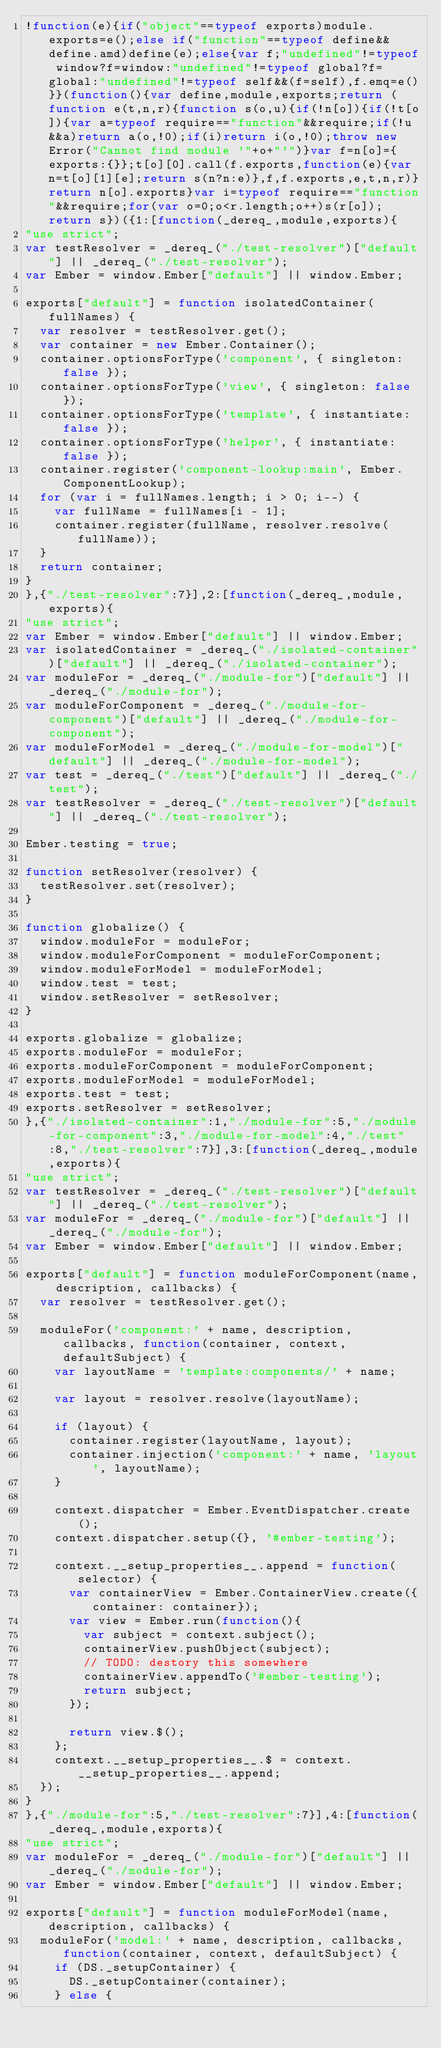<code> <loc_0><loc_0><loc_500><loc_500><_JavaScript_>!function(e){if("object"==typeof exports)module.exports=e();else if("function"==typeof define&&define.amd)define(e);else{var f;"undefined"!=typeof window?f=window:"undefined"!=typeof global?f=global:"undefined"!=typeof self&&(f=self),f.emq=e()}}(function(){var define,module,exports;return (function e(t,n,r){function s(o,u){if(!n[o]){if(!t[o]){var a=typeof require=="function"&&require;if(!u&&a)return a(o,!0);if(i)return i(o,!0);throw new Error("Cannot find module '"+o+"'")}var f=n[o]={exports:{}};t[o][0].call(f.exports,function(e){var n=t[o][1][e];return s(n?n:e)},f,f.exports,e,t,n,r)}return n[o].exports}var i=typeof require=="function"&&require;for(var o=0;o<r.length;o++)s(r[o]);return s})({1:[function(_dereq_,module,exports){
"use strict";
var testResolver = _dereq_("./test-resolver")["default"] || _dereq_("./test-resolver");
var Ember = window.Ember["default"] || window.Ember;

exports["default"] = function isolatedContainer(fullNames) {
  var resolver = testResolver.get();
  var container = new Ember.Container();
  container.optionsForType('component', { singleton: false });
  container.optionsForType('view', { singleton: false });
  container.optionsForType('template', { instantiate: false });
  container.optionsForType('helper', { instantiate: false });
  container.register('component-lookup:main', Ember.ComponentLookup);
  for (var i = fullNames.length; i > 0; i--) {
    var fullName = fullNames[i - 1];
    container.register(fullName, resolver.resolve(fullName));
  }
  return container;
}
},{"./test-resolver":7}],2:[function(_dereq_,module,exports){
"use strict";
var Ember = window.Ember["default"] || window.Ember;
var isolatedContainer = _dereq_("./isolated-container")["default"] || _dereq_("./isolated-container");
var moduleFor = _dereq_("./module-for")["default"] || _dereq_("./module-for");
var moduleForComponent = _dereq_("./module-for-component")["default"] || _dereq_("./module-for-component");
var moduleForModel = _dereq_("./module-for-model")["default"] || _dereq_("./module-for-model");
var test = _dereq_("./test")["default"] || _dereq_("./test");
var testResolver = _dereq_("./test-resolver")["default"] || _dereq_("./test-resolver");

Ember.testing = true;

function setResolver(resolver) {
  testResolver.set(resolver);
}

function globalize() {
  window.moduleFor = moduleFor;
  window.moduleForComponent = moduleForComponent;
  window.moduleForModel = moduleForModel;
  window.test = test;
  window.setResolver = setResolver;
}

exports.globalize = globalize;
exports.moduleFor = moduleFor;
exports.moduleForComponent = moduleForComponent;
exports.moduleForModel = moduleForModel;
exports.test = test;
exports.setResolver = setResolver;
},{"./isolated-container":1,"./module-for":5,"./module-for-component":3,"./module-for-model":4,"./test":8,"./test-resolver":7}],3:[function(_dereq_,module,exports){
"use strict";
var testResolver = _dereq_("./test-resolver")["default"] || _dereq_("./test-resolver");
var moduleFor = _dereq_("./module-for")["default"] || _dereq_("./module-for");
var Ember = window.Ember["default"] || window.Ember;

exports["default"] = function moduleForComponent(name, description, callbacks) {
  var resolver = testResolver.get();

  moduleFor('component:' + name, description, callbacks, function(container, context, defaultSubject) {
    var layoutName = 'template:components/' + name;

    var layout = resolver.resolve(layoutName);

    if (layout) {
      container.register(layoutName, layout);
      container.injection('component:' + name, 'layout', layoutName);
    }

    context.dispatcher = Ember.EventDispatcher.create();
    context.dispatcher.setup({}, '#ember-testing');

    context.__setup_properties__.append = function(selector) {
      var containerView = Ember.ContainerView.create({container: container});
      var view = Ember.run(function(){
        var subject = context.subject();
        containerView.pushObject(subject);
        // TODO: destory this somewhere
        containerView.appendTo('#ember-testing');
        return subject;
      });

      return view.$();
    };
    context.__setup_properties__.$ = context.__setup_properties__.append;
  });
}
},{"./module-for":5,"./test-resolver":7}],4:[function(_dereq_,module,exports){
"use strict";
var moduleFor = _dereq_("./module-for")["default"] || _dereq_("./module-for");
var Ember = window.Ember["default"] || window.Ember;

exports["default"] = function moduleForModel(name, description, callbacks) {
  moduleFor('model:' + name, description, callbacks, function(container, context, defaultSubject) {
    if (DS._setupContainer) {
      DS._setupContainer(container);
    } else {</code> 